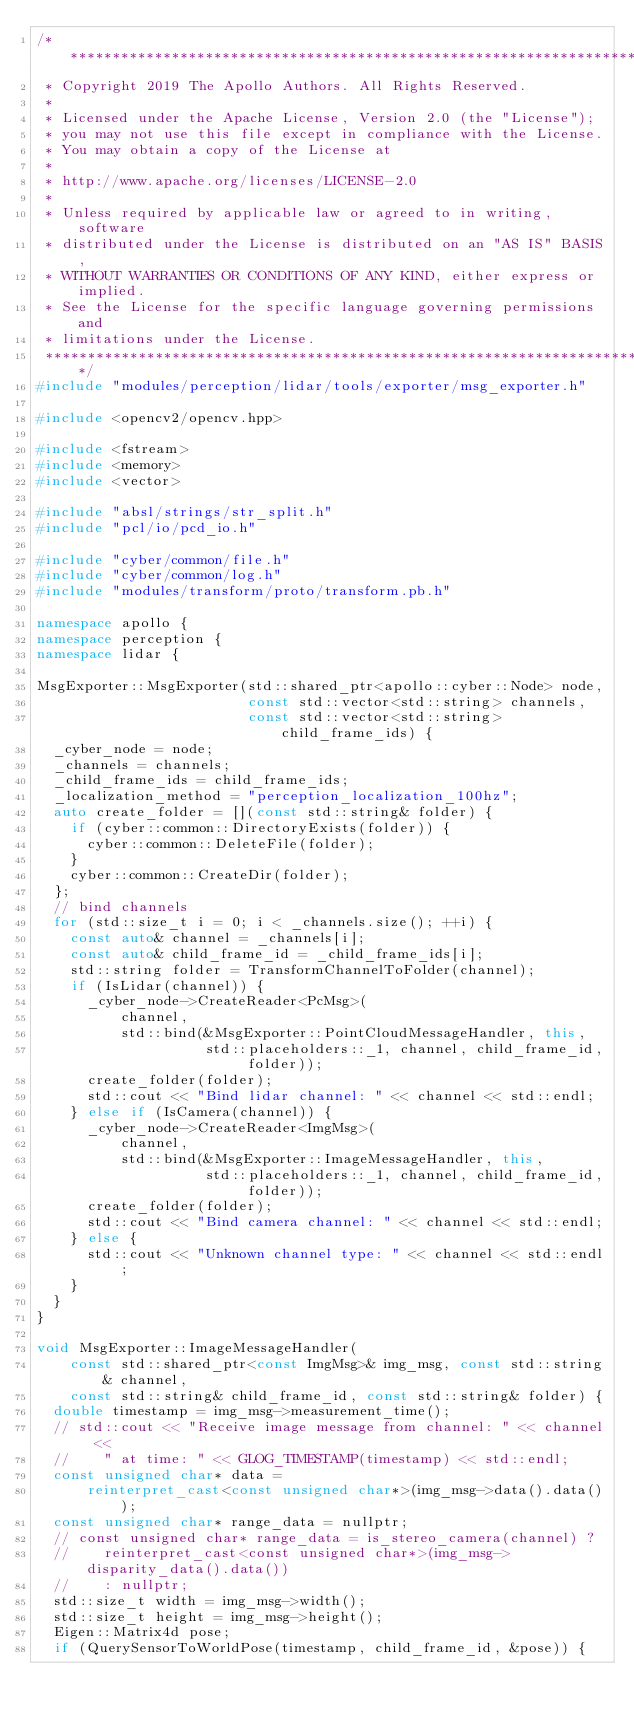Convert code to text. <code><loc_0><loc_0><loc_500><loc_500><_C++_>/******************************************************************************
 * Copyright 2019 The Apollo Authors. All Rights Reserved.
 *
 * Licensed under the Apache License, Version 2.0 (the "License");
 * you may not use this file except in compliance with the License.
 * You may obtain a copy of the License at
 *
 * http://www.apache.org/licenses/LICENSE-2.0
 *
 * Unless required by applicable law or agreed to in writing, software
 * distributed under the License is distributed on an "AS IS" BASIS,
 * WITHOUT WARRANTIES OR CONDITIONS OF ANY KIND, either express or implied.
 * See the License for the specific language governing permissions and
 * limitations under the License.
 *****************************************************************************/
#include "modules/perception/lidar/tools/exporter/msg_exporter.h"

#include <opencv2/opencv.hpp>

#include <fstream>
#include <memory>
#include <vector>

#include "absl/strings/str_split.h"
#include "pcl/io/pcd_io.h"

#include "cyber/common/file.h"
#include "cyber/common/log.h"
#include "modules/transform/proto/transform.pb.h"

namespace apollo {
namespace perception {
namespace lidar {

MsgExporter::MsgExporter(std::shared_ptr<apollo::cyber::Node> node,
                         const std::vector<std::string> channels,
                         const std::vector<std::string> child_frame_ids) {
  _cyber_node = node;
  _channels = channels;
  _child_frame_ids = child_frame_ids;
  _localization_method = "perception_localization_100hz";
  auto create_folder = [](const std::string& folder) {
    if (cyber::common::DirectoryExists(folder)) {
      cyber::common::DeleteFile(folder);
    }
    cyber::common::CreateDir(folder);
  };
  // bind channels
  for (std::size_t i = 0; i < _channels.size(); ++i) {
    const auto& channel = _channels[i];
    const auto& child_frame_id = _child_frame_ids[i];
    std::string folder = TransformChannelToFolder(channel);
    if (IsLidar(channel)) {
      _cyber_node->CreateReader<PcMsg>(
          channel,
          std::bind(&MsgExporter::PointCloudMessageHandler, this,
                    std::placeholders::_1, channel, child_frame_id, folder));
      create_folder(folder);
      std::cout << "Bind lidar channel: " << channel << std::endl;
    } else if (IsCamera(channel)) {
      _cyber_node->CreateReader<ImgMsg>(
          channel,
          std::bind(&MsgExporter::ImageMessageHandler, this,
                    std::placeholders::_1, channel, child_frame_id, folder));
      create_folder(folder);
      std::cout << "Bind camera channel: " << channel << std::endl;
    } else {
      std::cout << "Unknown channel type: " << channel << std::endl;
    }
  }
}

void MsgExporter::ImageMessageHandler(
    const std::shared_ptr<const ImgMsg>& img_msg, const std::string& channel,
    const std::string& child_frame_id, const std::string& folder) {
  double timestamp = img_msg->measurement_time();
  // std::cout << "Receive image message from channel: " << channel <<
  //    " at time: " << GLOG_TIMESTAMP(timestamp) << std::endl;
  const unsigned char* data =
      reinterpret_cast<const unsigned char*>(img_msg->data().data());
  const unsigned char* range_data = nullptr;
  // const unsigned char* range_data = is_stereo_camera(channel) ?
  //    reinterpret_cast<const unsigned char*>(img_msg->disparity_data().data())
  //    : nullptr;
  std::size_t width = img_msg->width();
  std::size_t height = img_msg->height();
  Eigen::Matrix4d pose;
  if (QuerySensorToWorldPose(timestamp, child_frame_id, &pose)) {</code> 